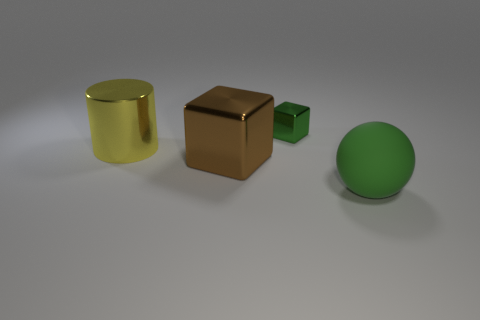Add 4 large rubber balls. How many objects exist? 8 Subtract all cylinders. How many objects are left? 3 Add 2 large matte things. How many large matte things are left? 3 Add 3 tiny gray rubber balls. How many tiny gray rubber balls exist? 3 Subtract 0 brown cylinders. How many objects are left? 4 Subtract all tiny green objects. Subtract all big yellow objects. How many objects are left? 2 